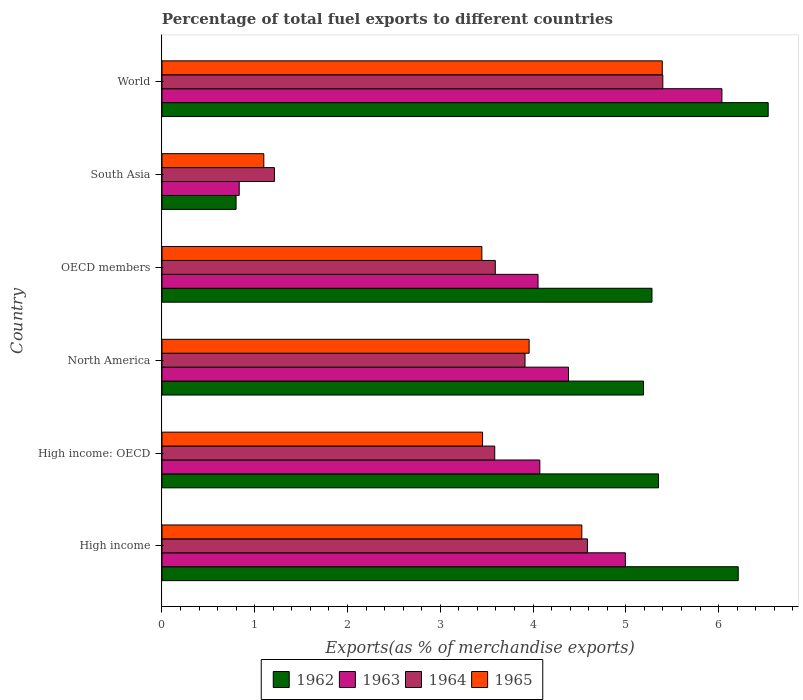How many different coloured bars are there?
Your answer should be compact. 4. Are the number of bars per tick equal to the number of legend labels?
Provide a succinct answer. Yes. How many bars are there on the 4th tick from the top?
Your answer should be very brief. 4. In how many cases, is the number of bars for a given country not equal to the number of legend labels?
Give a very brief answer. 0. What is the percentage of exports to different countries in 1965 in High income: OECD?
Your answer should be compact. 3.46. Across all countries, what is the maximum percentage of exports to different countries in 1963?
Ensure brevity in your answer.  6.04. Across all countries, what is the minimum percentage of exports to different countries in 1964?
Your response must be concise. 1.21. In which country was the percentage of exports to different countries in 1963 minimum?
Offer a terse response. South Asia. What is the total percentage of exports to different countries in 1962 in the graph?
Your answer should be very brief. 29.37. What is the difference between the percentage of exports to different countries in 1963 in High income: OECD and that in North America?
Provide a short and direct response. -0.31. What is the difference between the percentage of exports to different countries in 1965 in High income and the percentage of exports to different countries in 1963 in North America?
Provide a short and direct response. 0.14. What is the average percentage of exports to different countries in 1962 per country?
Offer a very short reply. 4.9. What is the difference between the percentage of exports to different countries in 1963 and percentage of exports to different countries in 1962 in World?
Give a very brief answer. -0.5. In how many countries, is the percentage of exports to different countries in 1964 greater than 5.8 %?
Make the answer very short. 0. What is the ratio of the percentage of exports to different countries in 1965 in High income: OECD to that in OECD members?
Provide a succinct answer. 1. Is the percentage of exports to different countries in 1962 in High income less than that in World?
Offer a very short reply. Yes. Is the difference between the percentage of exports to different countries in 1963 in OECD members and South Asia greater than the difference between the percentage of exports to different countries in 1962 in OECD members and South Asia?
Keep it short and to the point. No. What is the difference between the highest and the second highest percentage of exports to different countries in 1964?
Provide a succinct answer. 0.81. What is the difference between the highest and the lowest percentage of exports to different countries in 1964?
Make the answer very short. 4.19. Is it the case that in every country, the sum of the percentage of exports to different countries in 1964 and percentage of exports to different countries in 1963 is greater than the sum of percentage of exports to different countries in 1965 and percentage of exports to different countries in 1962?
Your answer should be very brief. No. What does the 1st bar from the top in South Asia represents?
Ensure brevity in your answer.  1965. What does the 4th bar from the bottom in South Asia represents?
Offer a very short reply. 1965. Is it the case that in every country, the sum of the percentage of exports to different countries in 1962 and percentage of exports to different countries in 1965 is greater than the percentage of exports to different countries in 1964?
Your answer should be compact. Yes. Are all the bars in the graph horizontal?
Offer a terse response. Yes. How many countries are there in the graph?
Offer a terse response. 6. Are the values on the major ticks of X-axis written in scientific E-notation?
Offer a terse response. No. Does the graph contain grids?
Make the answer very short. No. Where does the legend appear in the graph?
Provide a succinct answer. Bottom center. How are the legend labels stacked?
Your answer should be compact. Horizontal. What is the title of the graph?
Your answer should be very brief. Percentage of total fuel exports to different countries. What is the label or title of the X-axis?
Offer a terse response. Exports(as % of merchandise exports). What is the Exports(as % of merchandise exports) in 1962 in High income?
Make the answer very short. 6.21. What is the Exports(as % of merchandise exports) in 1963 in High income?
Your answer should be compact. 5. What is the Exports(as % of merchandise exports) of 1964 in High income?
Keep it short and to the point. 4.59. What is the Exports(as % of merchandise exports) of 1965 in High income?
Your answer should be compact. 4.53. What is the Exports(as % of merchandise exports) of 1962 in High income: OECD?
Your answer should be very brief. 5.35. What is the Exports(as % of merchandise exports) of 1963 in High income: OECD?
Your answer should be very brief. 4.07. What is the Exports(as % of merchandise exports) in 1964 in High income: OECD?
Provide a short and direct response. 3.59. What is the Exports(as % of merchandise exports) of 1965 in High income: OECD?
Provide a short and direct response. 3.46. What is the Exports(as % of merchandise exports) of 1962 in North America?
Make the answer very short. 5.19. What is the Exports(as % of merchandise exports) in 1963 in North America?
Give a very brief answer. 4.38. What is the Exports(as % of merchandise exports) in 1964 in North America?
Offer a very short reply. 3.91. What is the Exports(as % of merchandise exports) of 1965 in North America?
Offer a terse response. 3.96. What is the Exports(as % of merchandise exports) in 1962 in OECD members?
Offer a very short reply. 5.28. What is the Exports(as % of merchandise exports) of 1963 in OECD members?
Your response must be concise. 4.05. What is the Exports(as % of merchandise exports) of 1964 in OECD members?
Provide a succinct answer. 3.59. What is the Exports(as % of merchandise exports) in 1965 in OECD members?
Ensure brevity in your answer.  3.45. What is the Exports(as % of merchandise exports) in 1962 in South Asia?
Provide a short and direct response. 0.8. What is the Exports(as % of merchandise exports) of 1963 in South Asia?
Provide a succinct answer. 0.83. What is the Exports(as % of merchandise exports) in 1964 in South Asia?
Offer a very short reply. 1.21. What is the Exports(as % of merchandise exports) of 1965 in South Asia?
Your response must be concise. 1.1. What is the Exports(as % of merchandise exports) of 1962 in World?
Provide a succinct answer. 6.53. What is the Exports(as % of merchandise exports) of 1963 in World?
Offer a terse response. 6.04. What is the Exports(as % of merchandise exports) in 1964 in World?
Provide a short and direct response. 5.4. What is the Exports(as % of merchandise exports) in 1965 in World?
Your response must be concise. 5.39. Across all countries, what is the maximum Exports(as % of merchandise exports) in 1962?
Ensure brevity in your answer.  6.53. Across all countries, what is the maximum Exports(as % of merchandise exports) in 1963?
Your answer should be very brief. 6.04. Across all countries, what is the maximum Exports(as % of merchandise exports) of 1964?
Offer a very short reply. 5.4. Across all countries, what is the maximum Exports(as % of merchandise exports) in 1965?
Your answer should be compact. 5.39. Across all countries, what is the minimum Exports(as % of merchandise exports) in 1962?
Provide a succinct answer. 0.8. Across all countries, what is the minimum Exports(as % of merchandise exports) of 1963?
Provide a short and direct response. 0.83. Across all countries, what is the minimum Exports(as % of merchandise exports) in 1964?
Provide a short and direct response. 1.21. Across all countries, what is the minimum Exports(as % of merchandise exports) in 1965?
Keep it short and to the point. 1.1. What is the total Exports(as % of merchandise exports) of 1962 in the graph?
Your answer should be very brief. 29.37. What is the total Exports(as % of merchandise exports) of 1963 in the graph?
Provide a short and direct response. 24.37. What is the total Exports(as % of merchandise exports) of 1964 in the graph?
Offer a terse response. 22.29. What is the total Exports(as % of merchandise exports) in 1965 in the graph?
Give a very brief answer. 21.88. What is the difference between the Exports(as % of merchandise exports) in 1962 in High income and that in High income: OECD?
Your response must be concise. 0.86. What is the difference between the Exports(as % of merchandise exports) in 1963 in High income and that in High income: OECD?
Your answer should be very brief. 0.92. What is the difference between the Exports(as % of merchandise exports) in 1965 in High income and that in High income: OECD?
Offer a terse response. 1.07. What is the difference between the Exports(as % of merchandise exports) of 1963 in High income and that in North America?
Your answer should be compact. 0.61. What is the difference between the Exports(as % of merchandise exports) in 1964 in High income and that in North America?
Your response must be concise. 0.67. What is the difference between the Exports(as % of merchandise exports) of 1965 in High income and that in North America?
Your answer should be very brief. 0.57. What is the difference between the Exports(as % of merchandise exports) of 1962 in High income and that in OECD members?
Make the answer very short. 0.93. What is the difference between the Exports(as % of merchandise exports) in 1963 in High income and that in OECD members?
Provide a short and direct response. 0.94. What is the difference between the Exports(as % of merchandise exports) of 1964 in High income and that in OECD members?
Ensure brevity in your answer.  0.99. What is the difference between the Exports(as % of merchandise exports) of 1965 in High income and that in OECD members?
Your answer should be very brief. 1.08. What is the difference between the Exports(as % of merchandise exports) of 1962 in High income and that in South Asia?
Offer a terse response. 5.41. What is the difference between the Exports(as % of merchandise exports) of 1963 in High income and that in South Asia?
Offer a terse response. 4.16. What is the difference between the Exports(as % of merchandise exports) of 1964 in High income and that in South Asia?
Make the answer very short. 3.37. What is the difference between the Exports(as % of merchandise exports) in 1965 in High income and that in South Asia?
Your answer should be compact. 3.43. What is the difference between the Exports(as % of merchandise exports) of 1962 in High income and that in World?
Your response must be concise. -0.32. What is the difference between the Exports(as % of merchandise exports) of 1963 in High income and that in World?
Ensure brevity in your answer.  -1.04. What is the difference between the Exports(as % of merchandise exports) of 1964 in High income and that in World?
Keep it short and to the point. -0.81. What is the difference between the Exports(as % of merchandise exports) of 1965 in High income and that in World?
Ensure brevity in your answer.  -0.87. What is the difference between the Exports(as % of merchandise exports) of 1962 in High income: OECD and that in North America?
Offer a very short reply. 0.16. What is the difference between the Exports(as % of merchandise exports) of 1963 in High income: OECD and that in North America?
Provide a short and direct response. -0.31. What is the difference between the Exports(as % of merchandise exports) of 1964 in High income: OECD and that in North America?
Offer a terse response. -0.33. What is the difference between the Exports(as % of merchandise exports) of 1965 in High income: OECD and that in North America?
Your answer should be very brief. -0.5. What is the difference between the Exports(as % of merchandise exports) of 1962 in High income: OECD and that in OECD members?
Give a very brief answer. 0.07. What is the difference between the Exports(as % of merchandise exports) of 1963 in High income: OECD and that in OECD members?
Ensure brevity in your answer.  0.02. What is the difference between the Exports(as % of merchandise exports) of 1964 in High income: OECD and that in OECD members?
Ensure brevity in your answer.  -0.01. What is the difference between the Exports(as % of merchandise exports) in 1965 in High income: OECD and that in OECD members?
Offer a very short reply. 0.01. What is the difference between the Exports(as % of merchandise exports) of 1962 in High income: OECD and that in South Asia?
Ensure brevity in your answer.  4.55. What is the difference between the Exports(as % of merchandise exports) of 1963 in High income: OECD and that in South Asia?
Your answer should be very brief. 3.24. What is the difference between the Exports(as % of merchandise exports) of 1964 in High income: OECD and that in South Asia?
Offer a very short reply. 2.37. What is the difference between the Exports(as % of merchandise exports) in 1965 in High income: OECD and that in South Asia?
Offer a terse response. 2.36. What is the difference between the Exports(as % of merchandise exports) of 1962 in High income: OECD and that in World?
Give a very brief answer. -1.18. What is the difference between the Exports(as % of merchandise exports) of 1963 in High income: OECD and that in World?
Your answer should be compact. -1.96. What is the difference between the Exports(as % of merchandise exports) of 1964 in High income: OECD and that in World?
Provide a short and direct response. -1.81. What is the difference between the Exports(as % of merchandise exports) in 1965 in High income: OECD and that in World?
Your answer should be compact. -1.94. What is the difference between the Exports(as % of merchandise exports) of 1962 in North America and that in OECD members?
Your answer should be very brief. -0.09. What is the difference between the Exports(as % of merchandise exports) of 1963 in North America and that in OECD members?
Keep it short and to the point. 0.33. What is the difference between the Exports(as % of merchandise exports) in 1964 in North America and that in OECD members?
Keep it short and to the point. 0.32. What is the difference between the Exports(as % of merchandise exports) of 1965 in North America and that in OECD members?
Your answer should be very brief. 0.51. What is the difference between the Exports(as % of merchandise exports) of 1962 in North America and that in South Asia?
Provide a succinct answer. 4.39. What is the difference between the Exports(as % of merchandise exports) in 1963 in North America and that in South Asia?
Provide a succinct answer. 3.55. What is the difference between the Exports(as % of merchandise exports) of 1964 in North America and that in South Asia?
Provide a succinct answer. 2.7. What is the difference between the Exports(as % of merchandise exports) of 1965 in North America and that in South Asia?
Your response must be concise. 2.86. What is the difference between the Exports(as % of merchandise exports) of 1962 in North America and that in World?
Make the answer very short. -1.34. What is the difference between the Exports(as % of merchandise exports) in 1963 in North America and that in World?
Keep it short and to the point. -1.65. What is the difference between the Exports(as % of merchandise exports) in 1964 in North America and that in World?
Provide a succinct answer. -1.49. What is the difference between the Exports(as % of merchandise exports) of 1965 in North America and that in World?
Your answer should be very brief. -1.44. What is the difference between the Exports(as % of merchandise exports) in 1962 in OECD members and that in South Asia?
Provide a succinct answer. 4.48. What is the difference between the Exports(as % of merchandise exports) of 1963 in OECD members and that in South Asia?
Make the answer very short. 3.22. What is the difference between the Exports(as % of merchandise exports) in 1964 in OECD members and that in South Asia?
Offer a terse response. 2.38. What is the difference between the Exports(as % of merchandise exports) in 1965 in OECD members and that in South Asia?
Offer a terse response. 2.35. What is the difference between the Exports(as % of merchandise exports) in 1962 in OECD members and that in World?
Make the answer very short. -1.25. What is the difference between the Exports(as % of merchandise exports) in 1963 in OECD members and that in World?
Make the answer very short. -1.98. What is the difference between the Exports(as % of merchandise exports) in 1964 in OECD members and that in World?
Keep it short and to the point. -1.81. What is the difference between the Exports(as % of merchandise exports) in 1965 in OECD members and that in World?
Offer a very short reply. -1.94. What is the difference between the Exports(as % of merchandise exports) of 1962 in South Asia and that in World?
Offer a terse response. -5.74. What is the difference between the Exports(as % of merchandise exports) of 1963 in South Asia and that in World?
Give a very brief answer. -5.2. What is the difference between the Exports(as % of merchandise exports) in 1964 in South Asia and that in World?
Your answer should be very brief. -4.19. What is the difference between the Exports(as % of merchandise exports) in 1965 in South Asia and that in World?
Your answer should be very brief. -4.3. What is the difference between the Exports(as % of merchandise exports) of 1962 in High income and the Exports(as % of merchandise exports) of 1963 in High income: OECD?
Provide a succinct answer. 2.14. What is the difference between the Exports(as % of merchandise exports) of 1962 in High income and the Exports(as % of merchandise exports) of 1964 in High income: OECD?
Your answer should be very brief. 2.62. What is the difference between the Exports(as % of merchandise exports) in 1962 in High income and the Exports(as % of merchandise exports) in 1965 in High income: OECD?
Provide a succinct answer. 2.76. What is the difference between the Exports(as % of merchandise exports) of 1963 in High income and the Exports(as % of merchandise exports) of 1964 in High income: OECD?
Provide a short and direct response. 1.41. What is the difference between the Exports(as % of merchandise exports) of 1963 in High income and the Exports(as % of merchandise exports) of 1965 in High income: OECD?
Keep it short and to the point. 1.54. What is the difference between the Exports(as % of merchandise exports) of 1964 in High income and the Exports(as % of merchandise exports) of 1965 in High income: OECD?
Offer a terse response. 1.13. What is the difference between the Exports(as % of merchandise exports) of 1962 in High income and the Exports(as % of merchandise exports) of 1963 in North America?
Provide a succinct answer. 1.83. What is the difference between the Exports(as % of merchandise exports) of 1962 in High income and the Exports(as % of merchandise exports) of 1964 in North America?
Offer a very short reply. 2.3. What is the difference between the Exports(as % of merchandise exports) of 1962 in High income and the Exports(as % of merchandise exports) of 1965 in North America?
Offer a very short reply. 2.25. What is the difference between the Exports(as % of merchandise exports) in 1963 in High income and the Exports(as % of merchandise exports) in 1964 in North America?
Provide a succinct answer. 1.08. What is the difference between the Exports(as % of merchandise exports) in 1963 in High income and the Exports(as % of merchandise exports) in 1965 in North America?
Offer a very short reply. 1.04. What is the difference between the Exports(as % of merchandise exports) of 1964 in High income and the Exports(as % of merchandise exports) of 1965 in North America?
Offer a terse response. 0.63. What is the difference between the Exports(as % of merchandise exports) in 1962 in High income and the Exports(as % of merchandise exports) in 1963 in OECD members?
Ensure brevity in your answer.  2.16. What is the difference between the Exports(as % of merchandise exports) in 1962 in High income and the Exports(as % of merchandise exports) in 1964 in OECD members?
Give a very brief answer. 2.62. What is the difference between the Exports(as % of merchandise exports) of 1962 in High income and the Exports(as % of merchandise exports) of 1965 in OECD members?
Your answer should be compact. 2.76. What is the difference between the Exports(as % of merchandise exports) of 1963 in High income and the Exports(as % of merchandise exports) of 1964 in OECD members?
Give a very brief answer. 1.4. What is the difference between the Exports(as % of merchandise exports) in 1963 in High income and the Exports(as % of merchandise exports) in 1965 in OECD members?
Offer a terse response. 1.55. What is the difference between the Exports(as % of merchandise exports) in 1964 in High income and the Exports(as % of merchandise exports) in 1965 in OECD members?
Your answer should be very brief. 1.14. What is the difference between the Exports(as % of merchandise exports) in 1962 in High income and the Exports(as % of merchandise exports) in 1963 in South Asia?
Provide a succinct answer. 5.38. What is the difference between the Exports(as % of merchandise exports) in 1962 in High income and the Exports(as % of merchandise exports) in 1964 in South Asia?
Your answer should be very brief. 5. What is the difference between the Exports(as % of merchandise exports) of 1962 in High income and the Exports(as % of merchandise exports) of 1965 in South Asia?
Your response must be concise. 5.11. What is the difference between the Exports(as % of merchandise exports) in 1963 in High income and the Exports(as % of merchandise exports) in 1964 in South Asia?
Offer a terse response. 3.78. What is the difference between the Exports(as % of merchandise exports) of 1963 in High income and the Exports(as % of merchandise exports) of 1965 in South Asia?
Your answer should be very brief. 3.9. What is the difference between the Exports(as % of merchandise exports) of 1964 in High income and the Exports(as % of merchandise exports) of 1965 in South Asia?
Provide a short and direct response. 3.49. What is the difference between the Exports(as % of merchandise exports) of 1962 in High income and the Exports(as % of merchandise exports) of 1963 in World?
Make the answer very short. 0.18. What is the difference between the Exports(as % of merchandise exports) in 1962 in High income and the Exports(as % of merchandise exports) in 1964 in World?
Your answer should be very brief. 0.81. What is the difference between the Exports(as % of merchandise exports) of 1962 in High income and the Exports(as % of merchandise exports) of 1965 in World?
Offer a very short reply. 0.82. What is the difference between the Exports(as % of merchandise exports) in 1963 in High income and the Exports(as % of merchandise exports) in 1964 in World?
Keep it short and to the point. -0.4. What is the difference between the Exports(as % of merchandise exports) of 1963 in High income and the Exports(as % of merchandise exports) of 1965 in World?
Your response must be concise. -0.4. What is the difference between the Exports(as % of merchandise exports) of 1964 in High income and the Exports(as % of merchandise exports) of 1965 in World?
Offer a very short reply. -0.81. What is the difference between the Exports(as % of merchandise exports) of 1962 in High income: OECD and the Exports(as % of merchandise exports) of 1963 in North America?
Make the answer very short. 0.97. What is the difference between the Exports(as % of merchandise exports) of 1962 in High income: OECD and the Exports(as % of merchandise exports) of 1964 in North America?
Ensure brevity in your answer.  1.44. What is the difference between the Exports(as % of merchandise exports) of 1962 in High income: OECD and the Exports(as % of merchandise exports) of 1965 in North America?
Your answer should be very brief. 1.39. What is the difference between the Exports(as % of merchandise exports) of 1963 in High income: OECD and the Exports(as % of merchandise exports) of 1964 in North America?
Your answer should be very brief. 0.16. What is the difference between the Exports(as % of merchandise exports) of 1963 in High income: OECD and the Exports(as % of merchandise exports) of 1965 in North America?
Make the answer very short. 0.12. What is the difference between the Exports(as % of merchandise exports) of 1964 in High income: OECD and the Exports(as % of merchandise exports) of 1965 in North America?
Your answer should be compact. -0.37. What is the difference between the Exports(as % of merchandise exports) of 1962 in High income: OECD and the Exports(as % of merchandise exports) of 1963 in OECD members?
Provide a succinct answer. 1.3. What is the difference between the Exports(as % of merchandise exports) in 1962 in High income: OECD and the Exports(as % of merchandise exports) in 1964 in OECD members?
Ensure brevity in your answer.  1.76. What is the difference between the Exports(as % of merchandise exports) in 1962 in High income: OECD and the Exports(as % of merchandise exports) in 1965 in OECD members?
Offer a very short reply. 1.9. What is the difference between the Exports(as % of merchandise exports) in 1963 in High income: OECD and the Exports(as % of merchandise exports) in 1964 in OECD members?
Keep it short and to the point. 0.48. What is the difference between the Exports(as % of merchandise exports) in 1963 in High income: OECD and the Exports(as % of merchandise exports) in 1965 in OECD members?
Make the answer very short. 0.62. What is the difference between the Exports(as % of merchandise exports) of 1964 in High income: OECD and the Exports(as % of merchandise exports) of 1965 in OECD members?
Your answer should be very brief. 0.14. What is the difference between the Exports(as % of merchandise exports) in 1962 in High income: OECD and the Exports(as % of merchandise exports) in 1963 in South Asia?
Your answer should be very brief. 4.52. What is the difference between the Exports(as % of merchandise exports) in 1962 in High income: OECD and the Exports(as % of merchandise exports) in 1964 in South Asia?
Offer a very short reply. 4.14. What is the difference between the Exports(as % of merchandise exports) in 1962 in High income: OECD and the Exports(as % of merchandise exports) in 1965 in South Asia?
Your response must be concise. 4.25. What is the difference between the Exports(as % of merchandise exports) in 1963 in High income: OECD and the Exports(as % of merchandise exports) in 1964 in South Asia?
Provide a succinct answer. 2.86. What is the difference between the Exports(as % of merchandise exports) in 1963 in High income: OECD and the Exports(as % of merchandise exports) in 1965 in South Asia?
Your response must be concise. 2.98. What is the difference between the Exports(as % of merchandise exports) of 1964 in High income: OECD and the Exports(as % of merchandise exports) of 1965 in South Asia?
Ensure brevity in your answer.  2.49. What is the difference between the Exports(as % of merchandise exports) in 1962 in High income: OECD and the Exports(as % of merchandise exports) in 1963 in World?
Your response must be concise. -0.68. What is the difference between the Exports(as % of merchandise exports) of 1962 in High income: OECD and the Exports(as % of merchandise exports) of 1964 in World?
Your answer should be very brief. -0.05. What is the difference between the Exports(as % of merchandise exports) of 1962 in High income: OECD and the Exports(as % of merchandise exports) of 1965 in World?
Your response must be concise. -0.04. What is the difference between the Exports(as % of merchandise exports) in 1963 in High income: OECD and the Exports(as % of merchandise exports) in 1964 in World?
Make the answer very short. -1.33. What is the difference between the Exports(as % of merchandise exports) of 1963 in High income: OECD and the Exports(as % of merchandise exports) of 1965 in World?
Give a very brief answer. -1.32. What is the difference between the Exports(as % of merchandise exports) in 1964 in High income: OECD and the Exports(as % of merchandise exports) in 1965 in World?
Your response must be concise. -1.81. What is the difference between the Exports(as % of merchandise exports) in 1962 in North America and the Exports(as % of merchandise exports) in 1963 in OECD members?
Make the answer very short. 1.14. What is the difference between the Exports(as % of merchandise exports) in 1962 in North America and the Exports(as % of merchandise exports) in 1964 in OECD members?
Provide a short and direct response. 1.6. What is the difference between the Exports(as % of merchandise exports) in 1962 in North America and the Exports(as % of merchandise exports) in 1965 in OECD members?
Provide a succinct answer. 1.74. What is the difference between the Exports(as % of merchandise exports) of 1963 in North America and the Exports(as % of merchandise exports) of 1964 in OECD members?
Offer a terse response. 0.79. What is the difference between the Exports(as % of merchandise exports) of 1963 in North America and the Exports(as % of merchandise exports) of 1965 in OECD members?
Keep it short and to the point. 0.93. What is the difference between the Exports(as % of merchandise exports) of 1964 in North America and the Exports(as % of merchandise exports) of 1965 in OECD members?
Keep it short and to the point. 0.47. What is the difference between the Exports(as % of merchandise exports) of 1962 in North America and the Exports(as % of merchandise exports) of 1963 in South Asia?
Keep it short and to the point. 4.36. What is the difference between the Exports(as % of merchandise exports) of 1962 in North America and the Exports(as % of merchandise exports) of 1964 in South Asia?
Provide a succinct answer. 3.98. What is the difference between the Exports(as % of merchandise exports) of 1962 in North America and the Exports(as % of merchandise exports) of 1965 in South Asia?
Offer a terse response. 4.09. What is the difference between the Exports(as % of merchandise exports) of 1963 in North America and the Exports(as % of merchandise exports) of 1964 in South Asia?
Offer a very short reply. 3.17. What is the difference between the Exports(as % of merchandise exports) of 1963 in North America and the Exports(as % of merchandise exports) of 1965 in South Asia?
Your answer should be compact. 3.28. What is the difference between the Exports(as % of merchandise exports) in 1964 in North America and the Exports(as % of merchandise exports) in 1965 in South Asia?
Provide a short and direct response. 2.82. What is the difference between the Exports(as % of merchandise exports) of 1962 in North America and the Exports(as % of merchandise exports) of 1963 in World?
Ensure brevity in your answer.  -0.85. What is the difference between the Exports(as % of merchandise exports) of 1962 in North America and the Exports(as % of merchandise exports) of 1964 in World?
Your answer should be compact. -0.21. What is the difference between the Exports(as % of merchandise exports) of 1962 in North America and the Exports(as % of merchandise exports) of 1965 in World?
Your answer should be compact. -0.2. What is the difference between the Exports(as % of merchandise exports) in 1963 in North America and the Exports(as % of merchandise exports) in 1964 in World?
Your answer should be very brief. -1.02. What is the difference between the Exports(as % of merchandise exports) in 1963 in North America and the Exports(as % of merchandise exports) in 1965 in World?
Provide a short and direct response. -1.01. What is the difference between the Exports(as % of merchandise exports) in 1964 in North America and the Exports(as % of merchandise exports) in 1965 in World?
Keep it short and to the point. -1.48. What is the difference between the Exports(as % of merchandise exports) of 1962 in OECD members and the Exports(as % of merchandise exports) of 1963 in South Asia?
Keep it short and to the point. 4.45. What is the difference between the Exports(as % of merchandise exports) in 1962 in OECD members and the Exports(as % of merchandise exports) in 1964 in South Asia?
Provide a succinct answer. 4.07. What is the difference between the Exports(as % of merchandise exports) of 1962 in OECD members and the Exports(as % of merchandise exports) of 1965 in South Asia?
Give a very brief answer. 4.18. What is the difference between the Exports(as % of merchandise exports) of 1963 in OECD members and the Exports(as % of merchandise exports) of 1964 in South Asia?
Make the answer very short. 2.84. What is the difference between the Exports(as % of merchandise exports) in 1963 in OECD members and the Exports(as % of merchandise exports) in 1965 in South Asia?
Give a very brief answer. 2.96. What is the difference between the Exports(as % of merchandise exports) in 1964 in OECD members and the Exports(as % of merchandise exports) in 1965 in South Asia?
Offer a terse response. 2.5. What is the difference between the Exports(as % of merchandise exports) of 1962 in OECD members and the Exports(as % of merchandise exports) of 1963 in World?
Ensure brevity in your answer.  -0.75. What is the difference between the Exports(as % of merchandise exports) of 1962 in OECD members and the Exports(as % of merchandise exports) of 1964 in World?
Offer a terse response. -0.12. What is the difference between the Exports(as % of merchandise exports) in 1962 in OECD members and the Exports(as % of merchandise exports) in 1965 in World?
Make the answer very short. -0.11. What is the difference between the Exports(as % of merchandise exports) in 1963 in OECD members and the Exports(as % of merchandise exports) in 1964 in World?
Provide a succinct answer. -1.35. What is the difference between the Exports(as % of merchandise exports) of 1963 in OECD members and the Exports(as % of merchandise exports) of 1965 in World?
Provide a short and direct response. -1.34. What is the difference between the Exports(as % of merchandise exports) in 1964 in OECD members and the Exports(as % of merchandise exports) in 1965 in World?
Keep it short and to the point. -1.8. What is the difference between the Exports(as % of merchandise exports) in 1962 in South Asia and the Exports(as % of merchandise exports) in 1963 in World?
Ensure brevity in your answer.  -5.24. What is the difference between the Exports(as % of merchandise exports) in 1962 in South Asia and the Exports(as % of merchandise exports) in 1964 in World?
Your response must be concise. -4.6. What is the difference between the Exports(as % of merchandise exports) of 1962 in South Asia and the Exports(as % of merchandise exports) of 1965 in World?
Ensure brevity in your answer.  -4.59. What is the difference between the Exports(as % of merchandise exports) of 1963 in South Asia and the Exports(as % of merchandise exports) of 1964 in World?
Offer a very short reply. -4.57. What is the difference between the Exports(as % of merchandise exports) of 1963 in South Asia and the Exports(as % of merchandise exports) of 1965 in World?
Provide a short and direct response. -4.56. What is the difference between the Exports(as % of merchandise exports) in 1964 in South Asia and the Exports(as % of merchandise exports) in 1965 in World?
Provide a succinct answer. -4.18. What is the average Exports(as % of merchandise exports) of 1962 per country?
Give a very brief answer. 4.9. What is the average Exports(as % of merchandise exports) of 1963 per country?
Provide a short and direct response. 4.06. What is the average Exports(as % of merchandise exports) in 1964 per country?
Your answer should be compact. 3.72. What is the average Exports(as % of merchandise exports) in 1965 per country?
Your response must be concise. 3.65. What is the difference between the Exports(as % of merchandise exports) of 1962 and Exports(as % of merchandise exports) of 1963 in High income?
Your answer should be compact. 1.22. What is the difference between the Exports(as % of merchandise exports) in 1962 and Exports(as % of merchandise exports) in 1964 in High income?
Your answer should be very brief. 1.63. What is the difference between the Exports(as % of merchandise exports) of 1962 and Exports(as % of merchandise exports) of 1965 in High income?
Ensure brevity in your answer.  1.69. What is the difference between the Exports(as % of merchandise exports) in 1963 and Exports(as % of merchandise exports) in 1964 in High income?
Offer a terse response. 0.41. What is the difference between the Exports(as % of merchandise exports) of 1963 and Exports(as % of merchandise exports) of 1965 in High income?
Provide a succinct answer. 0.47. What is the difference between the Exports(as % of merchandise exports) in 1964 and Exports(as % of merchandise exports) in 1965 in High income?
Your answer should be compact. 0.06. What is the difference between the Exports(as % of merchandise exports) in 1962 and Exports(as % of merchandise exports) in 1963 in High income: OECD?
Your answer should be compact. 1.28. What is the difference between the Exports(as % of merchandise exports) of 1962 and Exports(as % of merchandise exports) of 1964 in High income: OECD?
Your answer should be compact. 1.77. What is the difference between the Exports(as % of merchandise exports) in 1962 and Exports(as % of merchandise exports) in 1965 in High income: OECD?
Keep it short and to the point. 1.9. What is the difference between the Exports(as % of merchandise exports) in 1963 and Exports(as % of merchandise exports) in 1964 in High income: OECD?
Offer a very short reply. 0.49. What is the difference between the Exports(as % of merchandise exports) of 1963 and Exports(as % of merchandise exports) of 1965 in High income: OECD?
Give a very brief answer. 0.62. What is the difference between the Exports(as % of merchandise exports) of 1964 and Exports(as % of merchandise exports) of 1965 in High income: OECD?
Keep it short and to the point. 0.13. What is the difference between the Exports(as % of merchandise exports) of 1962 and Exports(as % of merchandise exports) of 1963 in North America?
Make the answer very short. 0.81. What is the difference between the Exports(as % of merchandise exports) of 1962 and Exports(as % of merchandise exports) of 1964 in North America?
Keep it short and to the point. 1.28. What is the difference between the Exports(as % of merchandise exports) of 1962 and Exports(as % of merchandise exports) of 1965 in North America?
Provide a short and direct response. 1.23. What is the difference between the Exports(as % of merchandise exports) in 1963 and Exports(as % of merchandise exports) in 1964 in North America?
Provide a succinct answer. 0.47. What is the difference between the Exports(as % of merchandise exports) in 1963 and Exports(as % of merchandise exports) in 1965 in North America?
Offer a terse response. 0.42. What is the difference between the Exports(as % of merchandise exports) of 1964 and Exports(as % of merchandise exports) of 1965 in North America?
Your answer should be compact. -0.04. What is the difference between the Exports(as % of merchandise exports) in 1962 and Exports(as % of merchandise exports) in 1963 in OECD members?
Provide a succinct answer. 1.23. What is the difference between the Exports(as % of merchandise exports) of 1962 and Exports(as % of merchandise exports) of 1964 in OECD members?
Provide a succinct answer. 1.69. What is the difference between the Exports(as % of merchandise exports) of 1962 and Exports(as % of merchandise exports) of 1965 in OECD members?
Give a very brief answer. 1.83. What is the difference between the Exports(as % of merchandise exports) of 1963 and Exports(as % of merchandise exports) of 1964 in OECD members?
Offer a very short reply. 0.46. What is the difference between the Exports(as % of merchandise exports) in 1963 and Exports(as % of merchandise exports) in 1965 in OECD members?
Make the answer very short. 0.61. What is the difference between the Exports(as % of merchandise exports) in 1964 and Exports(as % of merchandise exports) in 1965 in OECD members?
Give a very brief answer. 0.14. What is the difference between the Exports(as % of merchandise exports) in 1962 and Exports(as % of merchandise exports) in 1963 in South Asia?
Ensure brevity in your answer.  -0.03. What is the difference between the Exports(as % of merchandise exports) in 1962 and Exports(as % of merchandise exports) in 1964 in South Asia?
Provide a succinct answer. -0.41. What is the difference between the Exports(as % of merchandise exports) in 1962 and Exports(as % of merchandise exports) in 1965 in South Asia?
Make the answer very short. -0.3. What is the difference between the Exports(as % of merchandise exports) in 1963 and Exports(as % of merchandise exports) in 1964 in South Asia?
Offer a very short reply. -0.38. What is the difference between the Exports(as % of merchandise exports) in 1963 and Exports(as % of merchandise exports) in 1965 in South Asia?
Offer a very short reply. -0.27. What is the difference between the Exports(as % of merchandise exports) in 1964 and Exports(as % of merchandise exports) in 1965 in South Asia?
Provide a short and direct response. 0.11. What is the difference between the Exports(as % of merchandise exports) of 1962 and Exports(as % of merchandise exports) of 1963 in World?
Provide a succinct answer. 0.5. What is the difference between the Exports(as % of merchandise exports) in 1962 and Exports(as % of merchandise exports) in 1964 in World?
Provide a short and direct response. 1.14. What is the difference between the Exports(as % of merchandise exports) in 1962 and Exports(as % of merchandise exports) in 1965 in World?
Keep it short and to the point. 1.14. What is the difference between the Exports(as % of merchandise exports) in 1963 and Exports(as % of merchandise exports) in 1964 in World?
Ensure brevity in your answer.  0.64. What is the difference between the Exports(as % of merchandise exports) of 1963 and Exports(as % of merchandise exports) of 1965 in World?
Provide a succinct answer. 0.64. What is the difference between the Exports(as % of merchandise exports) in 1964 and Exports(as % of merchandise exports) in 1965 in World?
Keep it short and to the point. 0.01. What is the ratio of the Exports(as % of merchandise exports) in 1962 in High income to that in High income: OECD?
Make the answer very short. 1.16. What is the ratio of the Exports(as % of merchandise exports) of 1963 in High income to that in High income: OECD?
Your answer should be very brief. 1.23. What is the ratio of the Exports(as % of merchandise exports) of 1964 in High income to that in High income: OECD?
Offer a very short reply. 1.28. What is the ratio of the Exports(as % of merchandise exports) in 1965 in High income to that in High income: OECD?
Offer a very short reply. 1.31. What is the ratio of the Exports(as % of merchandise exports) in 1962 in High income to that in North America?
Ensure brevity in your answer.  1.2. What is the ratio of the Exports(as % of merchandise exports) of 1963 in High income to that in North America?
Offer a very short reply. 1.14. What is the ratio of the Exports(as % of merchandise exports) of 1964 in High income to that in North America?
Offer a terse response. 1.17. What is the ratio of the Exports(as % of merchandise exports) of 1965 in High income to that in North America?
Make the answer very short. 1.14. What is the ratio of the Exports(as % of merchandise exports) in 1962 in High income to that in OECD members?
Provide a succinct answer. 1.18. What is the ratio of the Exports(as % of merchandise exports) of 1963 in High income to that in OECD members?
Provide a succinct answer. 1.23. What is the ratio of the Exports(as % of merchandise exports) in 1964 in High income to that in OECD members?
Provide a succinct answer. 1.28. What is the ratio of the Exports(as % of merchandise exports) in 1965 in High income to that in OECD members?
Make the answer very short. 1.31. What is the ratio of the Exports(as % of merchandise exports) of 1962 in High income to that in South Asia?
Your answer should be compact. 7.78. What is the ratio of the Exports(as % of merchandise exports) of 1963 in High income to that in South Asia?
Make the answer very short. 6. What is the ratio of the Exports(as % of merchandise exports) in 1964 in High income to that in South Asia?
Your response must be concise. 3.78. What is the ratio of the Exports(as % of merchandise exports) in 1965 in High income to that in South Asia?
Ensure brevity in your answer.  4.12. What is the ratio of the Exports(as % of merchandise exports) in 1962 in High income to that in World?
Give a very brief answer. 0.95. What is the ratio of the Exports(as % of merchandise exports) of 1963 in High income to that in World?
Your response must be concise. 0.83. What is the ratio of the Exports(as % of merchandise exports) of 1964 in High income to that in World?
Provide a succinct answer. 0.85. What is the ratio of the Exports(as % of merchandise exports) of 1965 in High income to that in World?
Provide a short and direct response. 0.84. What is the ratio of the Exports(as % of merchandise exports) in 1962 in High income: OECD to that in North America?
Provide a succinct answer. 1.03. What is the ratio of the Exports(as % of merchandise exports) of 1963 in High income: OECD to that in North America?
Your response must be concise. 0.93. What is the ratio of the Exports(as % of merchandise exports) of 1964 in High income: OECD to that in North America?
Give a very brief answer. 0.92. What is the ratio of the Exports(as % of merchandise exports) of 1965 in High income: OECD to that in North America?
Your answer should be compact. 0.87. What is the ratio of the Exports(as % of merchandise exports) of 1962 in High income: OECD to that in OECD members?
Offer a very short reply. 1.01. What is the ratio of the Exports(as % of merchandise exports) in 1963 in High income: OECD to that in OECD members?
Offer a terse response. 1. What is the ratio of the Exports(as % of merchandise exports) of 1964 in High income: OECD to that in OECD members?
Offer a very short reply. 1. What is the ratio of the Exports(as % of merchandise exports) of 1962 in High income: OECD to that in South Asia?
Give a very brief answer. 6.7. What is the ratio of the Exports(as % of merchandise exports) in 1963 in High income: OECD to that in South Asia?
Provide a succinct answer. 4.89. What is the ratio of the Exports(as % of merchandise exports) in 1964 in High income: OECD to that in South Asia?
Offer a terse response. 2.96. What is the ratio of the Exports(as % of merchandise exports) in 1965 in High income: OECD to that in South Asia?
Keep it short and to the point. 3.15. What is the ratio of the Exports(as % of merchandise exports) in 1962 in High income: OECD to that in World?
Your answer should be very brief. 0.82. What is the ratio of the Exports(as % of merchandise exports) of 1963 in High income: OECD to that in World?
Provide a succinct answer. 0.67. What is the ratio of the Exports(as % of merchandise exports) in 1964 in High income: OECD to that in World?
Offer a terse response. 0.66. What is the ratio of the Exports(as % of merchandise exports) in 1965 in High income: OECD to that in World?
Provide a short and direct response. 0.64. What is the ratio of the Exports(as % of merchandise exports) in 1962 in North America to that in OECD members?
Offer a very short reply. 0.98. What is the ratio of the Exports(as % of merchandise exports) of 1963 in North America to that in OECD members?
Provide a succinct answer. 1.08. What is the ratio of the Exports(as % of merchandise exports) in 1964 in North America to that in OECD members?
Provide a succinct answer. 1.09. What is the ratio of the Exports(as % of merchandise exports) of 1965 in North America to that in OECD members?
Your answer should be compact. 1.15. What is the ratio of the Exports(as % of merchandise exports) of 1962 in North America to that in South Asia?
Your response must be concise. 6.5. What is the ratio of the Exports(as % of merchandise exports) in 1963 in North America to that in South Asia?
Keep it short and to the point. 5.26. What is the ratio of the Exports(as % of merchandise exports) in 1964 in North America to that in South Asia?
Make the answer very short. 3.23. What is the ratio of the Exports(as % of merchandise exports) in 1965 in North America to that in South Asia?
Provide a succinct answer. 3.61. What is the ratio of the Exports(as % of merchandise exports) of 1962 in North America to that in World?
Your answer should be compact. 0.79. What is the ratio of the Exports(as % of merchandise exports) of 1963 in North America to that in World?
Your answer should be compact. 0.73. What is the ratio of the Exports(as % of merchandise exports) in 1964 in North America to that in World?
Keep it short and to the point. 0.72. What is the ratio of the Exports(as % of merchandise exports) in 1965 in North America to that in World?
Ensure brevity in your answer.  0.73. What is the ratio of the Exports(as % of merchandise exports) of 1962 in OECD members to that in South Asia?
Your response must be concise. 6.61. What is the ratio of the Exports(as % of merchandise exports) in 1963 in OECD members to that in South Asia?
Give a very brief answer. 4.87. What is the ratio of the Exports(as % of merchandise exports) in 1964 in OECD members to that in South Asia?
Provide a succinct answer. 2.96. What is the ratio of the Exports(as % of merchandise exports) in 1965 in OECD members to that in South Asia?
Keep it short and to the point. 3.14. What is the ratio of the Exports(as % of merchandise exports) in 1962 in OECD members to that in World?
Your response must be concise. 0.81. What is the ratio of the Exports(as % of merchandise exports) in 1963 in OECD members to that in World?
Your response must be concise. 0.67. What is the ratio of the Exports(as % of merchandise exports) in 1964 in OECD members to that in World?
Your response must be concise. 0.67. What is the ratio of the Exports(as % of merchandise exports) in 1965 in OECD members to that in World?
Make the answer very short. 0.64. What is the ratio of the Exports(as % of merchandise exports) of 1962 in South Asia to that in World?
Your response must be concise. 0.12. What is the ratio of the Exports(as % of merchandise exports) of 1963 in South Asia to that in World?
Give a very brief answer. 0.14. What is the ratio of the Exports(as % of merchandise exports) in 1964 in South Asia to that in World?
Make the answer very short. 0.22. What is the ratio of the Exports(as % of merchandise exports) of 1965 in South Asia to that in World?
Make the answer very short. 0.2. What is the difference between the highest and the second highest Exports(as % of merchandise exports) of 1962?
Offer a terse response. 0.32. What is the difference between the highest and the second highest Exports(as % of merchandise exports) of 1963?
Offer a terse response. 1.04. What is the difference between the highest and the second highest Exports(as % of merchandise exports) of 1964?
Your answer should be very brief. 0.81. What is the difference between the highest and the second highest Exports(as % of merchandise exports) of 1965?
Your response must be concise. 0.87. What is the difference between the highest and the lowest Exports(as % of merchandise exports) in 1962?
Your response must be concise. 5.74. What is the difference between the highest and the lowest Exports(as % of merchandise exports) of 1963?
Your answer should be very brief. 5.2. What is the difference between the highest and the lowest Exports(as % of merchandise exports) of 1964?
Make the answer very short. 4.19. What is the difference between the highest and the lowest Exports(as % of merchandise exports) of 1965?
Your answer should be very brief. 4.3. 